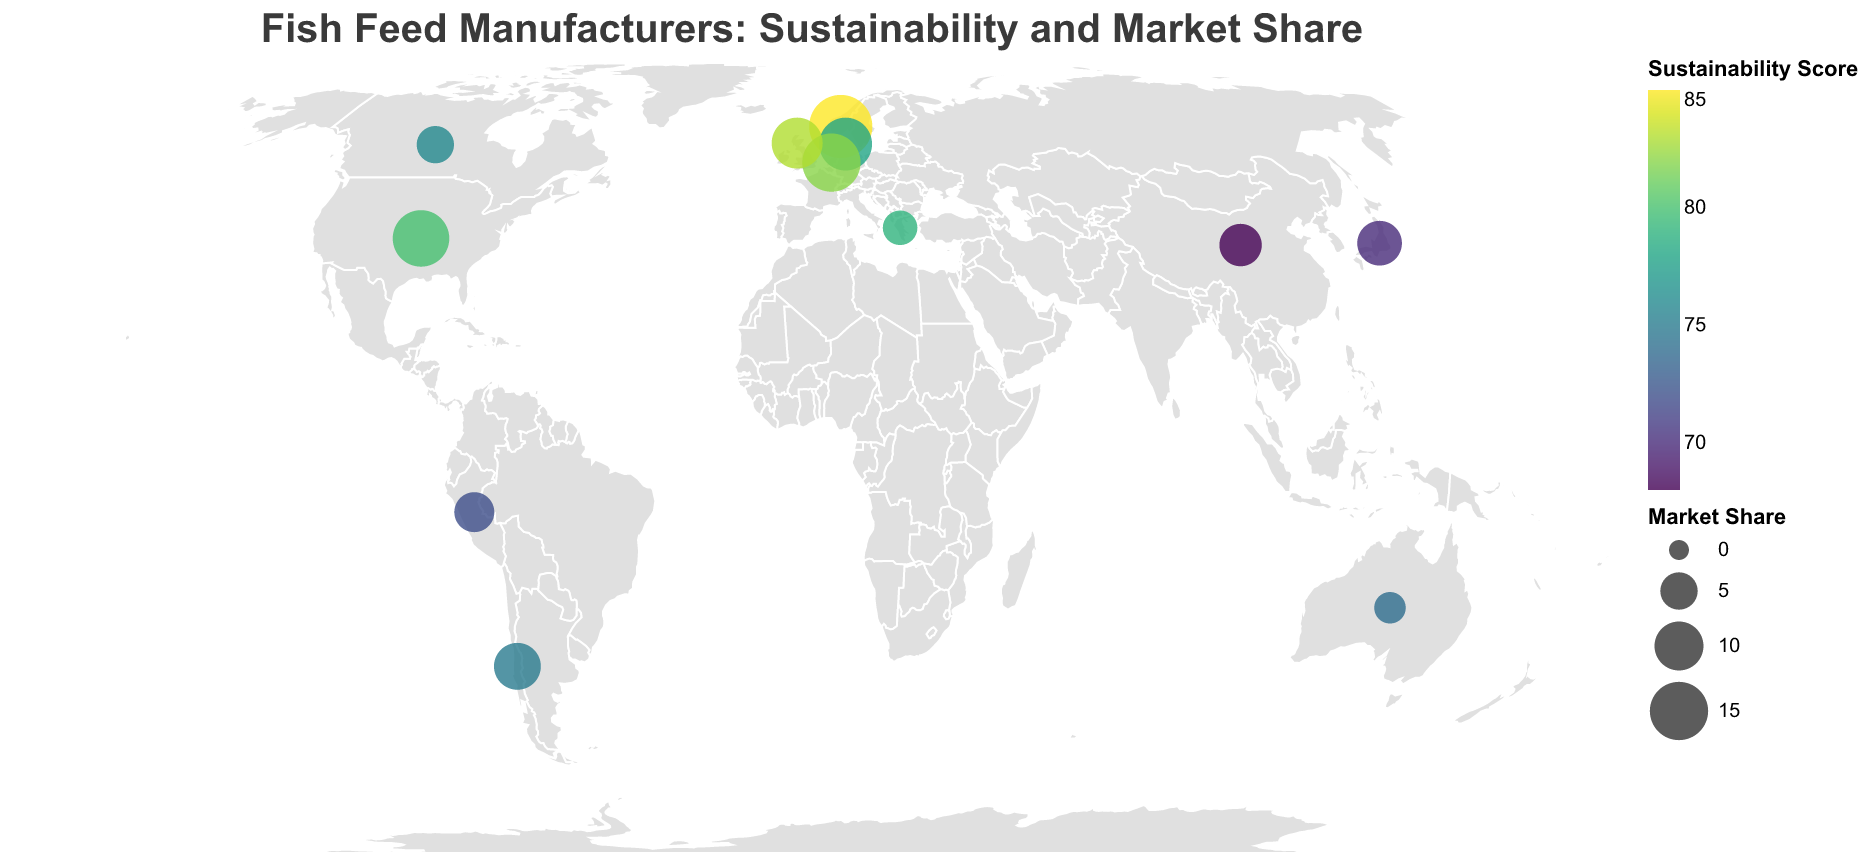What is the title of the plot? The title of the plot is usually located at the top and provides a summary of what the plot is about. Here, the title is "Fish Feed Manufacturers: Sustainability and Market Share."
Answer: Fish Feed Manufacturers: Sustainability and Market Share Which region has the highest Market Share and what is it? Look for the largest circle, which indicates the highest Market Share based on size. The largest circle is located in Norway, with a Market Share of 18.
Answer: Norway, 18 Which manufacturer has the lowest Sustainability Score and what is it? Identify the small dark circle, as a lower Sustainability Score implies a darker color. Tongwei, located in China, has the darkest color with a score of 68.
Answer: Tongwei, 68 How many manufacturers have a Sustainability Score above 80? Count the circles with colors corresponding to a Sustainability Score above 80. BioMar (Norway), Skretting (Netherlands), BioMar UK (Scotland) all have scores above 80.
Answer: 3 What is the average Sustainability Score of manufacturers from Europe? Identify the European regions (Norway, Denmark, Netherlands, Scotland, Greece), then add their scores and divide by the number of regions: (85 + 78 + 82 + 83 + 79) / 5 = 81.4
Answer: 81.4 Which manufacturer has the second largest Market Share and what is it? Identify the second largest circle. Aller Aqua (Denmark) has a Market Share of 12.
Answer: Aller Aqua, 12 Compare the Sustainability Scores of Cargill Aqua Nutrition (United States) and each manufacturer in Europe. Who has a higher score? Compare Cargill Aqua Nutrition's score (80) with scores from European manufacturers (85, 78, 82, 83, 79). Cargill Aqua Nutrition has a lower score compared to BioMar (Norway), Skretting (Netherlands), BioMar UK (Scotland) and Biomar Hellenic (Greece), but higher than Aller Aqua (Denmark).
Answer: Cargill Aqua Nutrition has a higher score than Aller Aqua only Which region in Asia has the lowest Sustainability Score and what is it? From the Asian regions in the plot (Japan, China), find the lowest score. Tongwei in China has a score of 68.
Answer: China, 68 How does the Market Share of BioMar UK (Scotland) compare to Salmofood (Chile)? Compare the Market Share values: BioMar UK (11) and Salmofood (9). BioMar UK has a larger Market Share than Salmofood.
Answer: BioMar UK has a larger Market Share Which manufacturer should the company target for acquisition if they are looking for the highest combined Sustainability Score and Market Share? Consider both highest scores and Market Share. BioMar in Norway has the highest combined value (Sustainability Score 85 + Market Share 18 = 103).
Answer: BioMar, Norway 